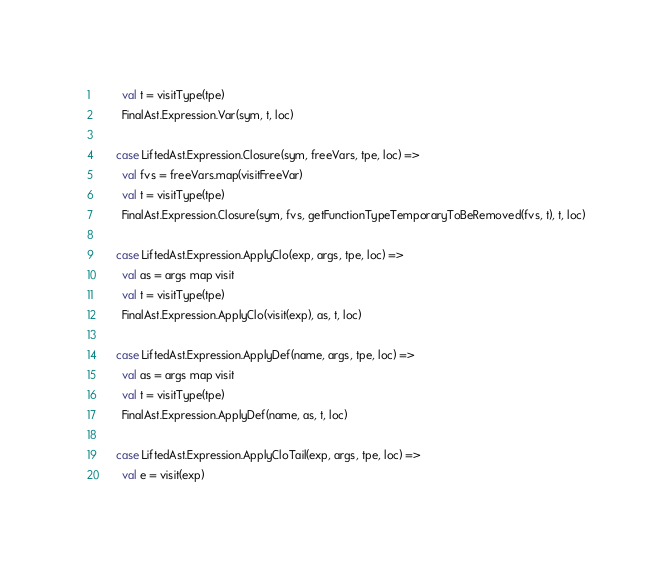Convert code to text. <code><loc_0><loc_0><loc_500><loc_500><_Scala_>        val t = visitType(tpe)
        FinalAst.Expression.Var(sym, t, loc)

      case LiftedAst.Expression.Closure(sym, freeVars, tpe, loc) =>
        val fvs = freeVars.map(visitFreeVar)
        val t = visitType(tpe)
        FinalAst.Expression.Closure(sym, fvs, getFunctionTypeTemporaryToBeRemoved(fvs, t), t, loc)

      case LiftedAst.Expression.ApplyClo(exp, args, tpe, loc) =>
        val as = args map visit
        val t = visitType(tpe)
        FinalAst.Expression.ApplyClo(visit(exp), as, t, loc)

      case LiftedAst.Expression.ApplyDef(name, args, tpe, loc) =>
        val as = args map visit
        val t = visitType(tpe)
        FinalAst.Expression.ApplyDef(name, as, t, loc)

      case LiftedAst.Expression.ApplyCloTail(exp, args, tpe, loc) =>
        val e = visit(exp)</code> 